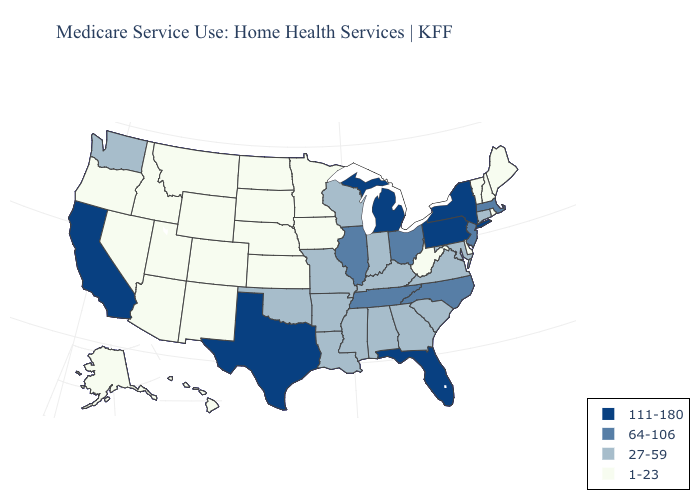Does Delaware have the lowest value in the South?
Be succinct. Yes. Does Arkansas have the same value as Nevada?
Concise answer only. No. Does Illinois have the same value as Utah?
Give a very brief answer. No. What is the lowest value in states that border New Mexico?
Write a very short answer. 1-23. What is the value of Illinois?
Write a very short answer. 64-106. Does Indiana have a higher value than North Dakota?
Keep it brief. Yes. Among the states that border Texas , which have the lowest value?
Concise answer only. New Mexico. Does the map have missing data?
Short answer required. No. Among the states that border Tennessee , does Arkansas have the highest value?
Keep it brief. No. What is the lowest value in states that border Texas?
Answer briefly. 1-23. What is the highest value in states that border Maine?
Write a very short answer. 1-23. Name the states that have a value in the range 27-59?
Keep it brief. Alabama, Arkansas, Connecticut, Georgia, Indiana, Kentucky, Louisiana, Maryland, Mississippi, Missouri, Oklahoma, South Carolina, Virginia, Washington, Wisconsin. Among the states that border Ohio , does Michigan have the highest value?
Write a very short answer. Yes. What is the value of Tennessee?
Keep it brief. 64-106. Does Tennessee have the same value as North Carolina?
Short answer required. Yes. 